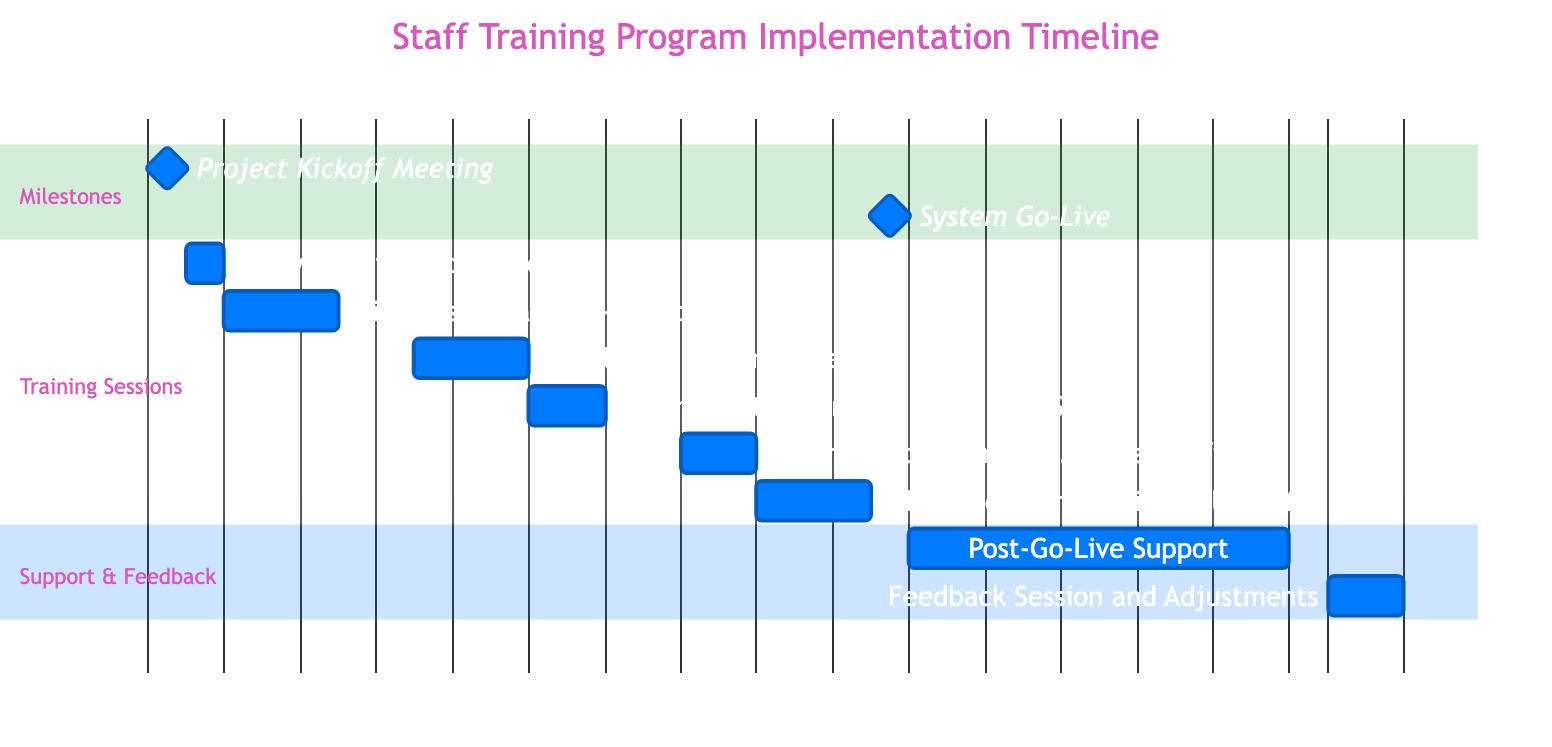What is the duration of the Initial User Training - Front Desk Staff? The diagram indicates that the Initial User Training for Front Desk Staff lasts for 3 days, from January 3 to January 5, 2024.
Answer: 3 days What date does the System Go-Live occur? According to the diagram, the System Go-Live is scheduled for January 20, 2024, marked as a milestone event.
Answer: January 20, 2024 How many days are dedicated to Post-Go-Live Support? The diagram shows that Post-Go-Live Support spans 10 days, from January 21 to January 30, 2024.
Answer: 10 days What is the start date of Intermediate Training for Medical Staff? The diagram indicates that Intermediate Training for Medical Staff starts on January 15, 2024.
Answer: January 15, 2024 Which training session overlaps with the Initial User Training - Medical Staff? The Initial User Training for Medical Staff overlaps with the next training session after it, the Intermediate Training for Front Desk Staff, which starts on January 11, 2024.
Answer: Intermediate Training - Front Desk Staff How many days are scheduled between the Project Kickoff Meeting and the first training session? The Project Kickoff Meeting is on January 1, 2024, and the first training session (Software Introduction) is on January 2, 2024. Thus, there is a gap of 1 day between them.
Answer: 1 day What is the last task listed in the Gantt chart before the Feedback Session and Adjustments? Based on the diagram, the last task listed before the Feedback Session is Post-Go-Live Support, which runs from January 21 to January 30, 2024.
Answer: Post-Go-Live Support How many total training sessions are there? The diagram includes a total of 6 training sessions scheduled throughout the implementation timeline.
Answer: 6 training sessions 